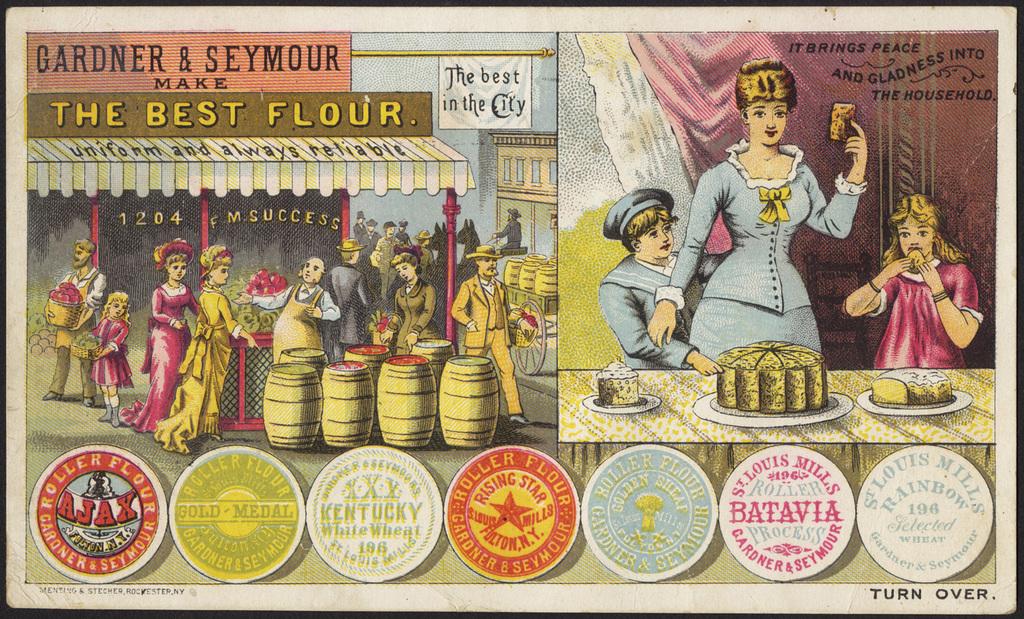Who owns the flour store?
Provide a short and direct response. Gardner & seymour. What is the best?
Offer a very short reply. Flour. 